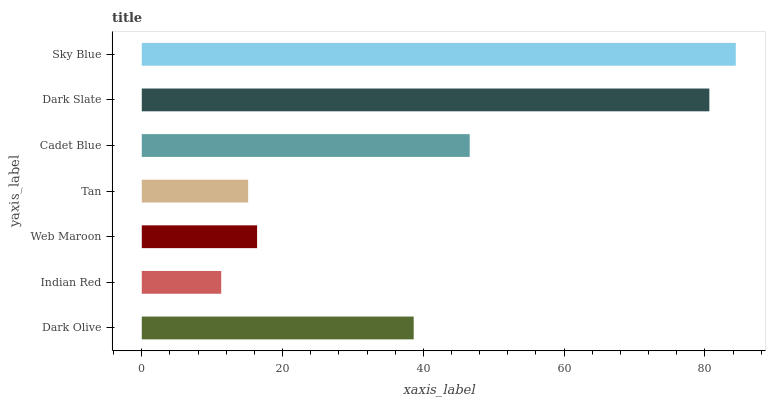Is Indian Red the minimum?
Answer yes or no. Yes. Is Sky Blue the maximum?
Answer yes or no. Yes. Is Web Maroon the minimum?
Answer yes or no. No. Is Web Maroon the maximum?
Answer yes or no. No. Is Web Maroon greater than Indian Red?
Answer yes or no. Yes. Is Indian Red less than Web Maroon?
Answer yes or no. Yes. Is Indian Red greater than Web Maroon?
Answer yes or no. No. Is Web Maroon less than Indian Red?
Answer yes or no. No. Is Dark Olive the high median?
Answer yes or no. Yes. Is Dark Olive the low median?
Answer yes or no. Yes. Is Sky Blue the high median?
Answer yes or no. No. Is Web Maroon the low median?
Answer yes or no. No. 